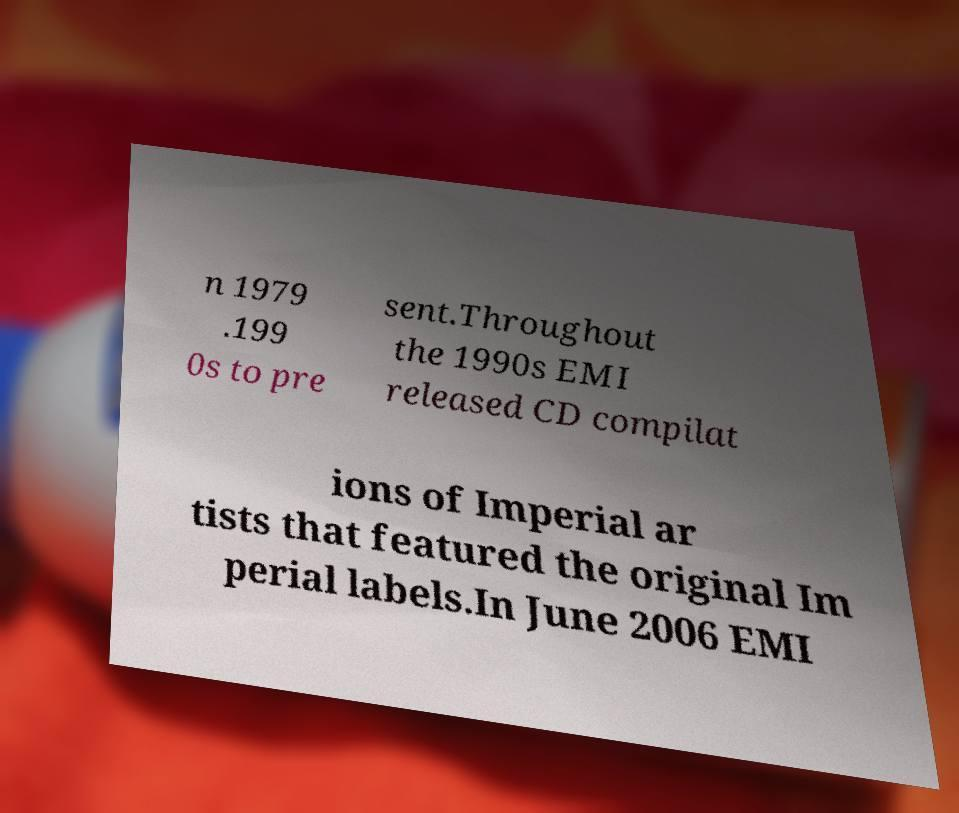Could you extract and type out the text from this image? n 1979 .199 0s to pre sent.Throughout the 1990s EMI released CD compilat ions of Imperial ar tists that featured the original Im perial labels.In June 2006 EMI 